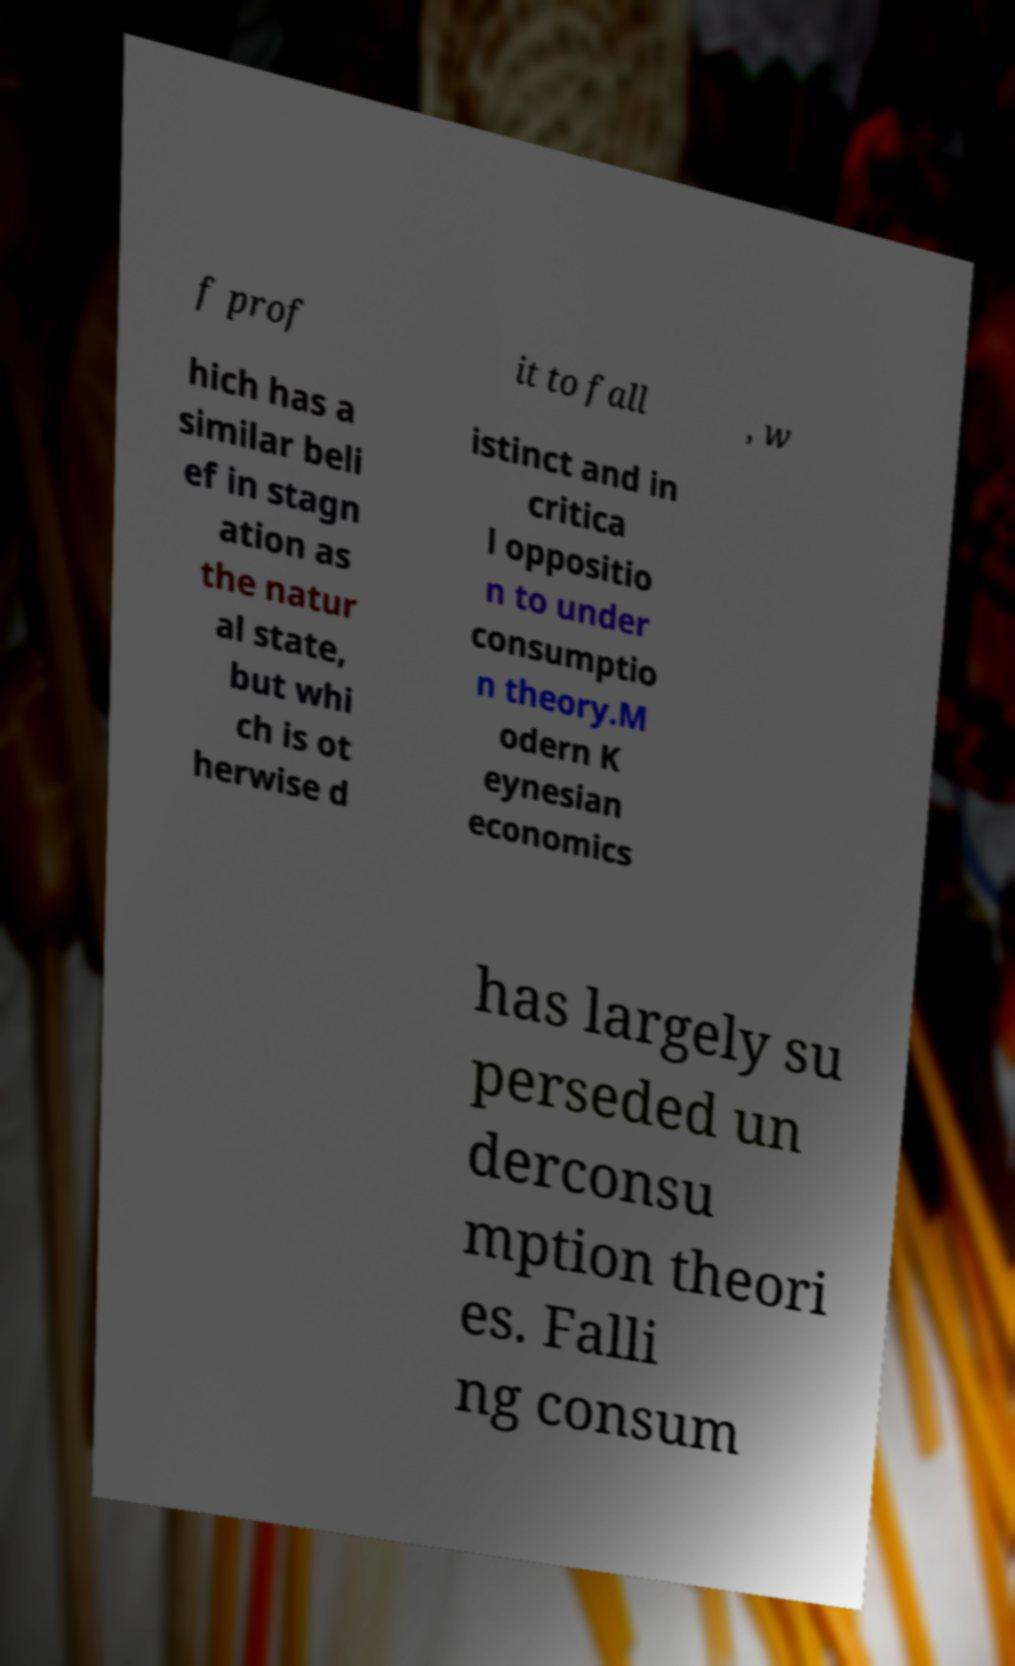Can you accurately transcribe the text from the provided image for me? f prof it to fall , w hich has a similar beli ef in stagn ation as the natur al state, but whi ch is ot herwise d istinct and in critica l oppositio n to under consumptio n theory.M odern K eynesian economics has largely su perseded un derconsu mption theori es. Falli ng consum 